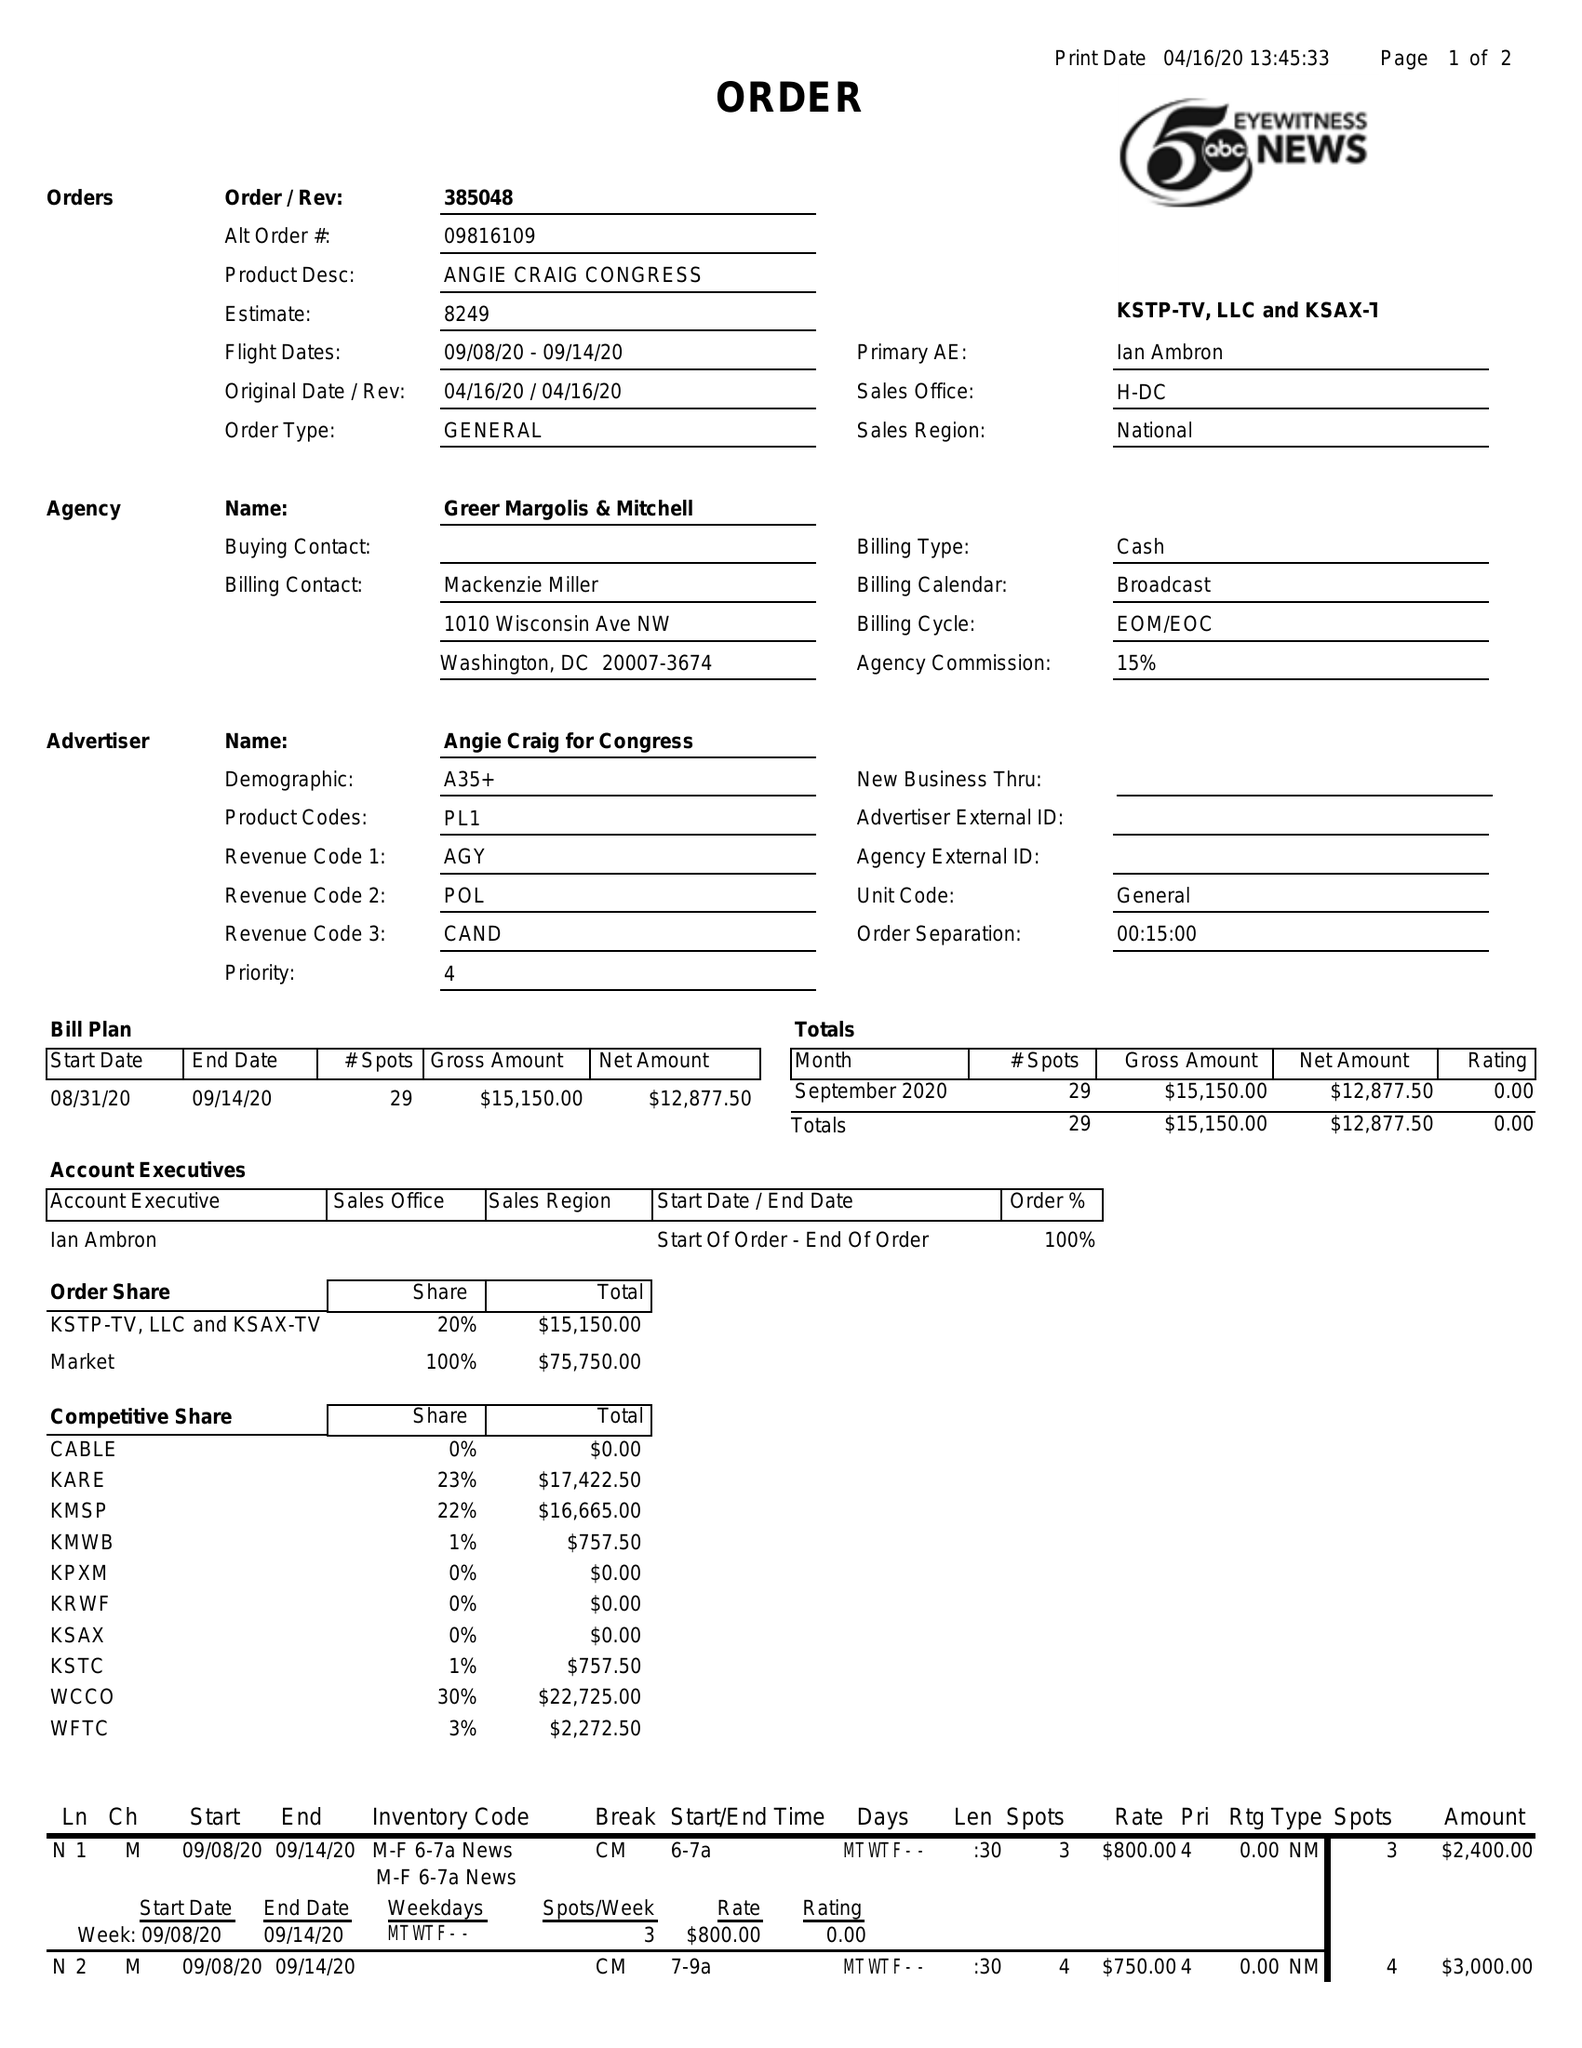What is the value for the flight_from?
Answer the question using a single word or phrase. 09/08/20 